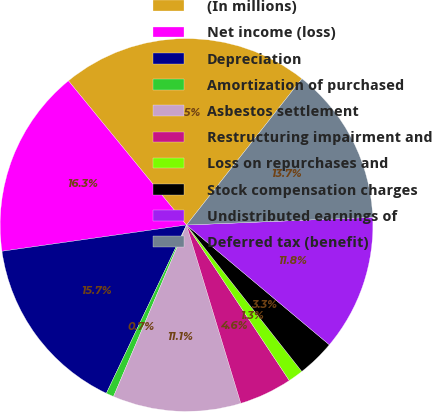<chart> <loc_0><loc_0><loc_500><loc_500><pie_chart><fcel>(In millions)<fcel>Net income (loss)<fcel>Depreciation<fcel>Amortization of purchased<fcel>Asbestos settlement<fcel>Restructuring impairment and<fcel>Loss on repurchases and<fcel>Stock compensation charges<fcel>Undistributed earnings of<fcel>Deferred tax (benefit)<nl><fcel>21.55%<fcel>16.33%<fcel>15.68%<fcel>0.67%<fcel>11.11%<fcel>4.59%<fcel>1.32%<fcel>3.28%<fcel>11.76%<fcel>13.72%<nl></chart> 